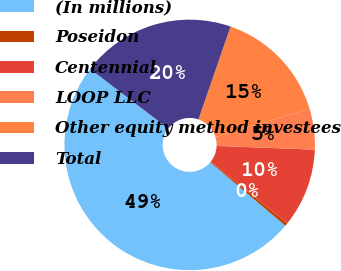Convert chart. <chart><loc_0><loc_0><loc_500><loc_500><pie_chart><fcel>(In millions)<fcel>Poseidon<fcel>Centennial<fcel>LOOP LLC<fcel>Other equity method investees<fcel>Total<nl><fcel>49.22%<fcel>0.39%<fcel>10.16%<fcel>5.27%<fcel>15.04%<fcel>19.92%<nl></chart> 